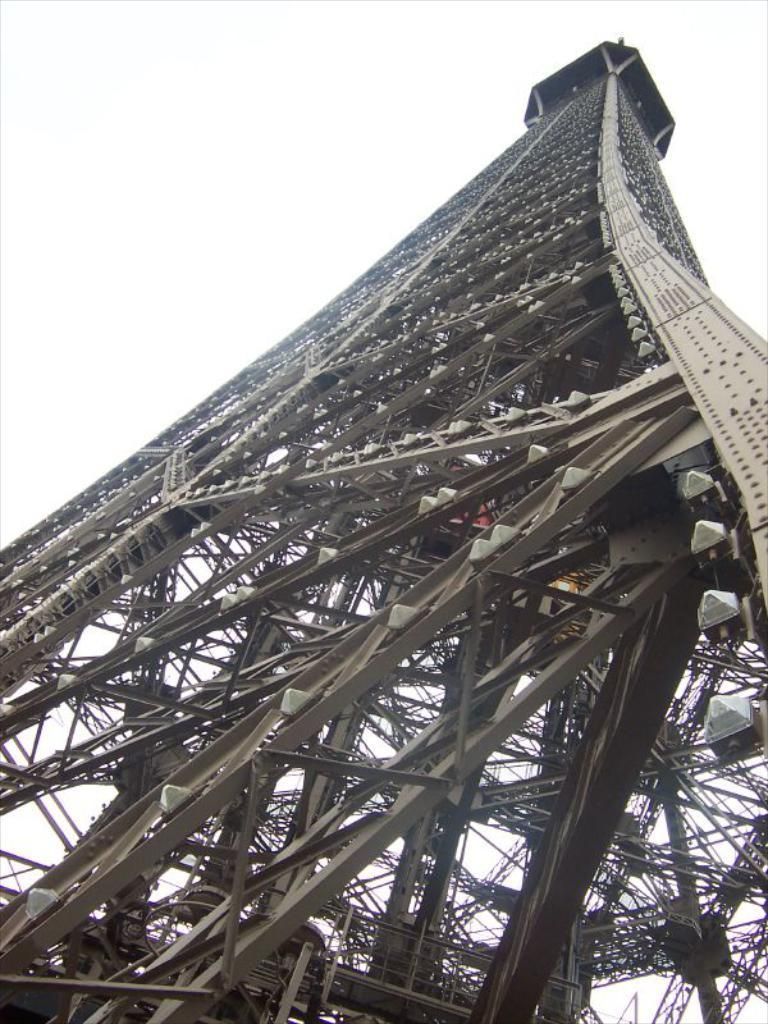What structure is the main subject of the image? There is a tower in the image. From what perspective is the tower being viewed? The tower is being viewed from the bottom. What type of friction can be seen between the tower and the ground in the image? There is no friction visible between the tower and the ground in the image, as it is a static representation of the structure. 